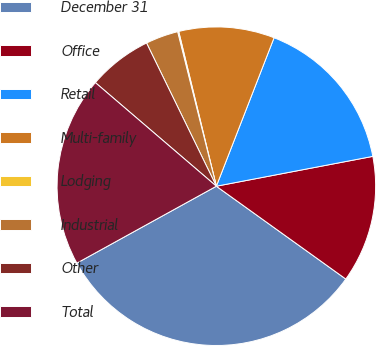Convert chart. <chart><loc_0><loc_0><loc_500><loc_500><pie_chart><fcel>December 31<fcel>Office<fcel>Retail<fcel>Multi-family<fcel>Lodging<fcel>Industrial<fcel>Other<fcel>Total<nl><fcel>32.08%<fcel>12.9%<fcel>16.1%<fcel>9.7%<fcel>0.11%<fcel>3.31%<fcel>6.51%<fcel>19.29%<nl></chart> 